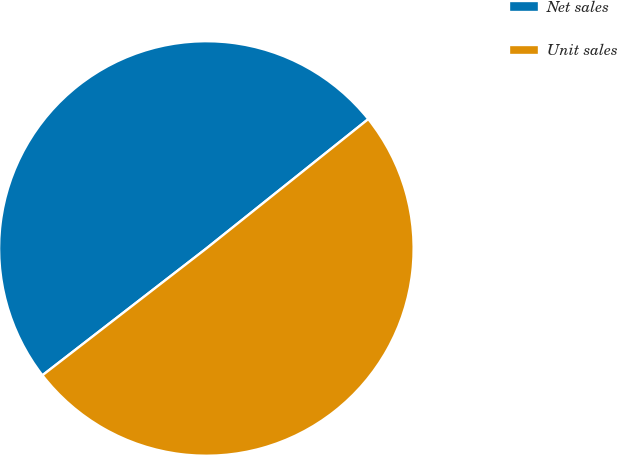<chart> <loc_0><loc_0><loc_500><loc_500><pie_chart><fcel>Net sales<fcel>Unit sales<nl><fcel>49.75%<fcel>50.25%<nl></chart> 